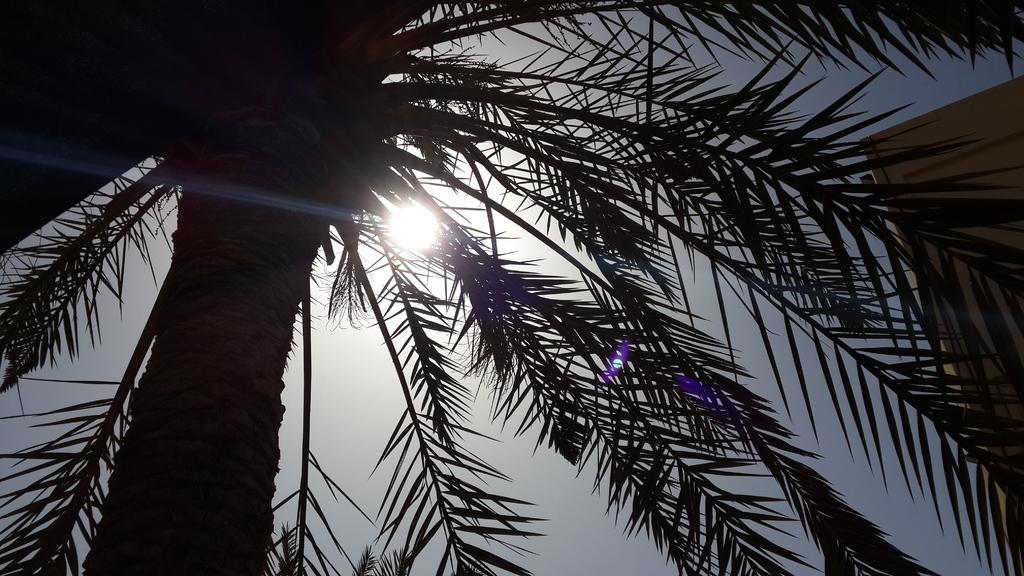Can you describe this image briefly? In this image I can see on the left side there is a tree, in the middle there is the sun in the sky. 